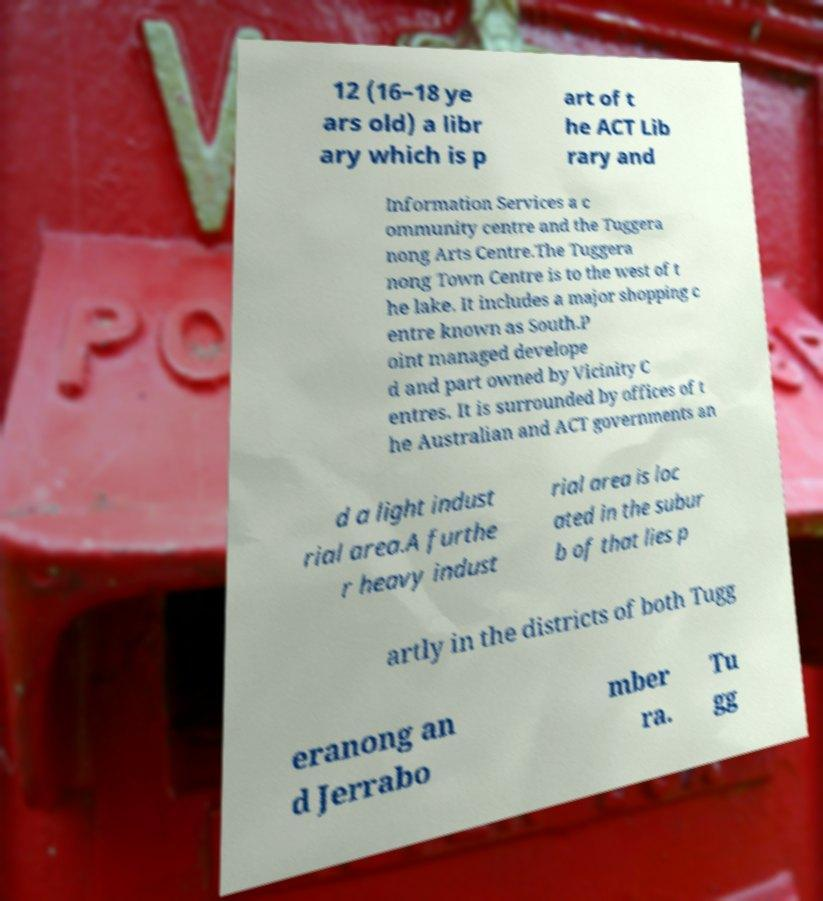Can you accurately transcribe the text from the provided image for me? 12 (16–18 ye ars old) a libr ary which is p art of t he ACT Lib rary and Information Services a c ommunity centre and the Tuggera nong Arts Centre.The Tuggera nong Town Centre is to the west of t he lake. It includes a major shopping c entre known as South.P oint managed develope d and part owned by Vicinity C entres. It is surrounded by offices of t he Australian and ACT governments an d a light indust rial area.A furthe r heavy indust rial area is loc ated in the subur b of that lies p artly in the districts of both Tugg eranong an d Jerrabo mber ra. Tu gg 